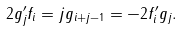<formula> <loc_0><loc_0><loc_500><loc_500>2 g ^ { \prime } _ { j } f _ { i } = j g _ { i + j - 1 } = - 2 f ^ { \prime } _ { i } g _ { j } .</formula> 